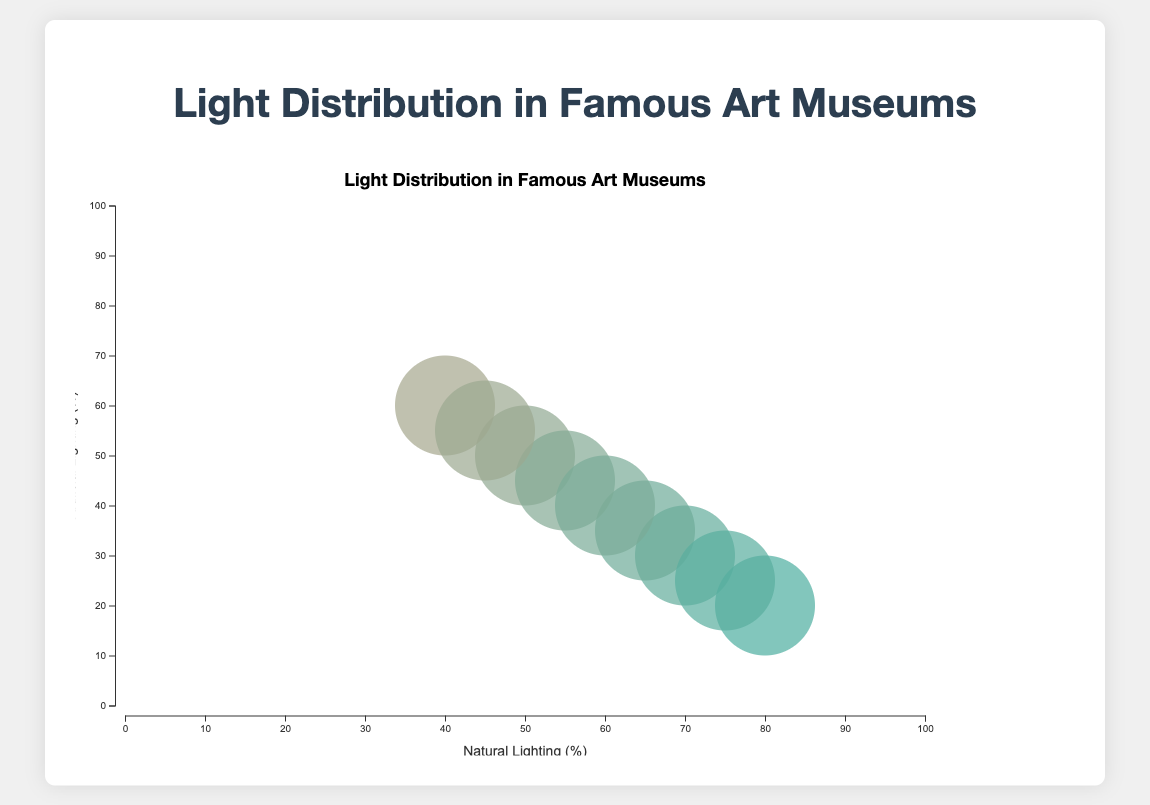What is the title of the chart? The title of the chart is centered at the top of the figure, indicating its main topic.
Answer: Light Distribution in Famous Art Museums What are the x-axis and y-axis labels? The x-axis label is located at the horizontal center below the axis, and the y-axis label is rotated 90 degrees counterclockwise at the vertical center of the y-axis.
Answer: Natural Lighting (%) and Artificial Lighting (%) Which museum has the highest percentage of natural lighting? By examining the x-axis where the natural lighting percentages are plotted, the museum with the highest x-value represents the one with the highest percentage of natural lighting.
Answer: The Uffizi Gallery How does the artificial lighting of Louvre Museum compare with that of Rijksmuseum? Locate both museums on the y-axis, the Louvre Museum has a y-value representing 30%, while the Rijksmuseum has a y-value representing 45%. Comparing these two values shows their differences.
Answer: Louvre Museum has less artificial lighting Which museum has the smallest bubble size? Bubble size represents the combined percentage of natural and artificial lighting. Identify the smallest bubble on the plot visually.
Answer: The Uffizi Gallery What would be the median natural lighting percentage among these museums? The median value is found by arranging all natural lighting percentages in ascending order and picking the middle value.
Answer: 60% Which two museums have equal percentages of natural and artificial lighting? Identify the bubbles where the x and y values are identical. This condition meets at one point on the bubble chart.
Answer: The Metropolitan Museum of Art Arrange the museums in descending order of their artificial lighting percentage. List the y-values in descending order and match them to their respective museums.
Answer: Vatican Museums, National Gallery of Art, The Metropolitan Museum of Art, Rijksmuseum, Museo Nacional del Prado, The British Museum, Louvre Museum, Hermitage Museum, The Uffizi Gallery What is the sum of natural lighting percentages for Louvre Museum and Museo Nacional del Prado? Find the natural lighting percentages for both museums and add them together: 70% for Louvre Museum and 60% for Museo Nacional del Prado.
Answer: 130% Which museum has the most balanced lighting distribution, meaning the least difference between natural and artificial lighting? Calculate the absolute difference between the natural and artificial lighting percentages for each museum and identify the smallest difference.
Answer: The Metropolitan Museum of Art 